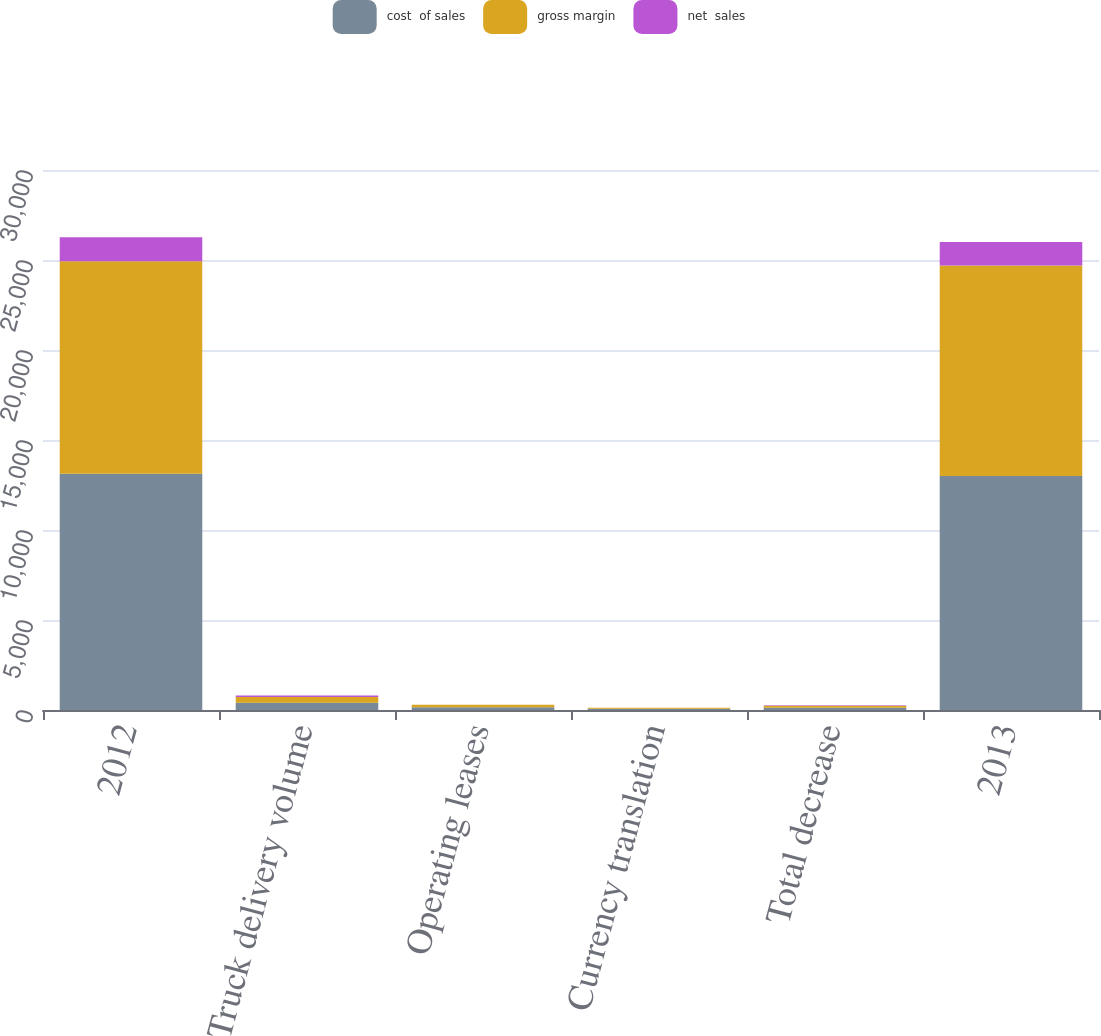Convert chart. <chart><loc_0><loc_0><loc_500><loc_500><stacked_bar_chart><ecel><fcel>2012<fcel>Truck delivery volume<fcel>Operating leases<fcel>Currency translation<fcel>Total decrease<fcel>2013<nl><fcel>cost  of sales<fcel>13131.5<fcel>399.7<fcel>149<fcel>64.5<fcel>128.6<fcel>13002.9<nl><fcel>gross margin<fcel>11794<fcel>324.5<fcel>142.4<fcel>57.2<fcel>102.1<fcel>11691.9<nl><fcel>net  sales<fcel>1337.5<fcel>75.2<fcel>6.6<fcel>7.3<fcel>26.5<fcel>1311<nl></chart> 